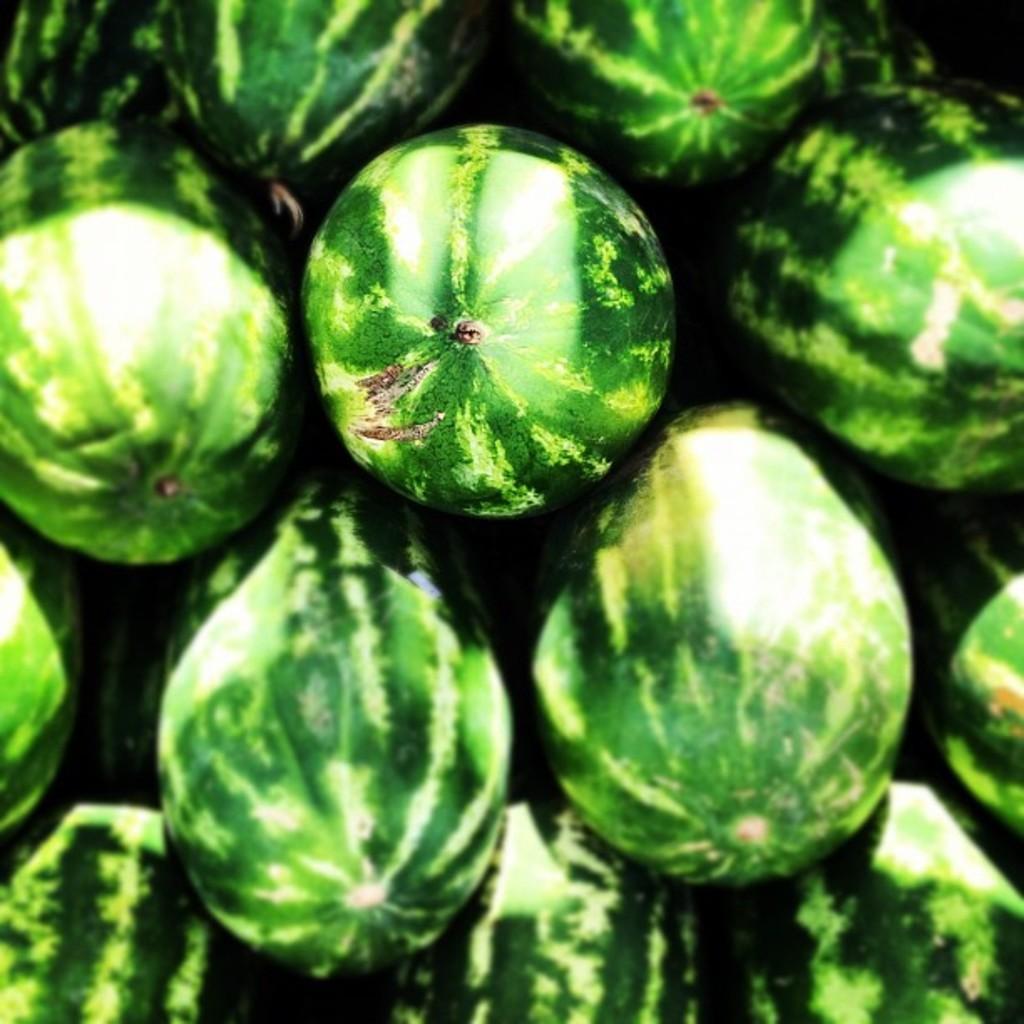Describe this image in one or two sentences. In this image I can see few green color watermelons. 